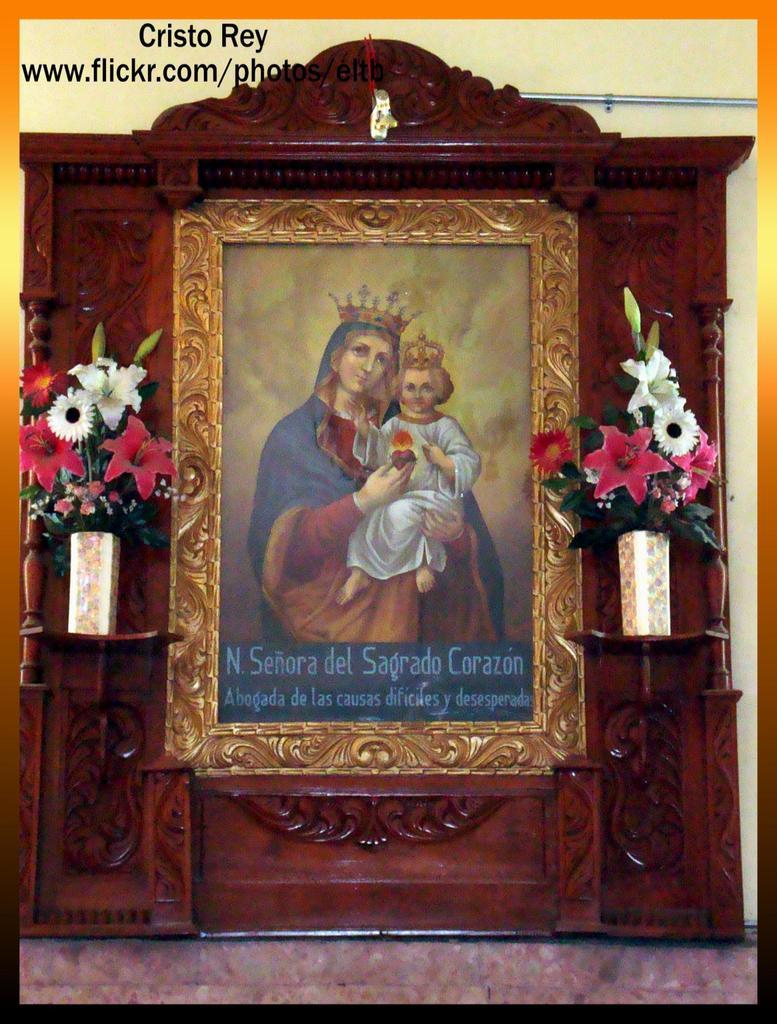Is that written on english?
Ensure brevity in your answer.  No. Which company card is this?
Offer a terse response. Cristo rey. 